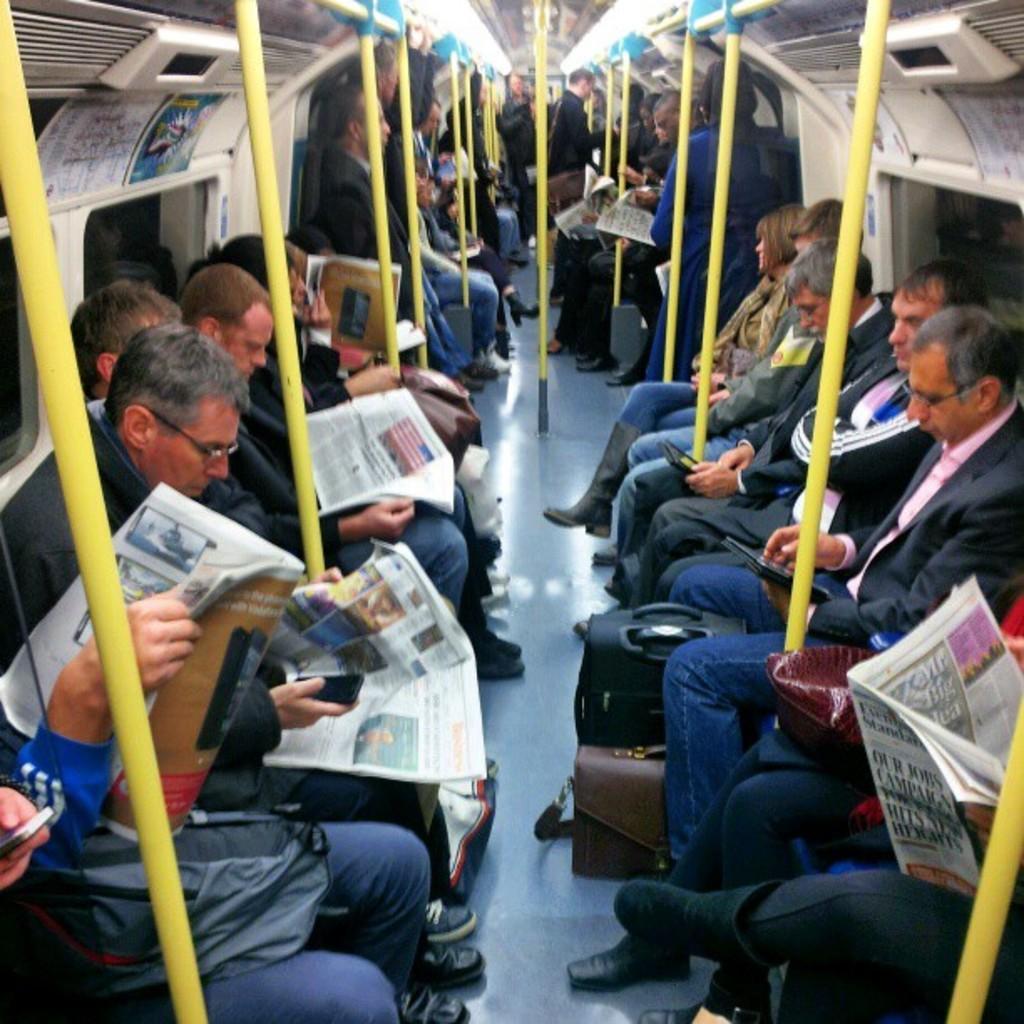How would you summarize this image in a sentence or two? In this image I can see a group of men are sitting in the train, it looks like an inside part of a train. 